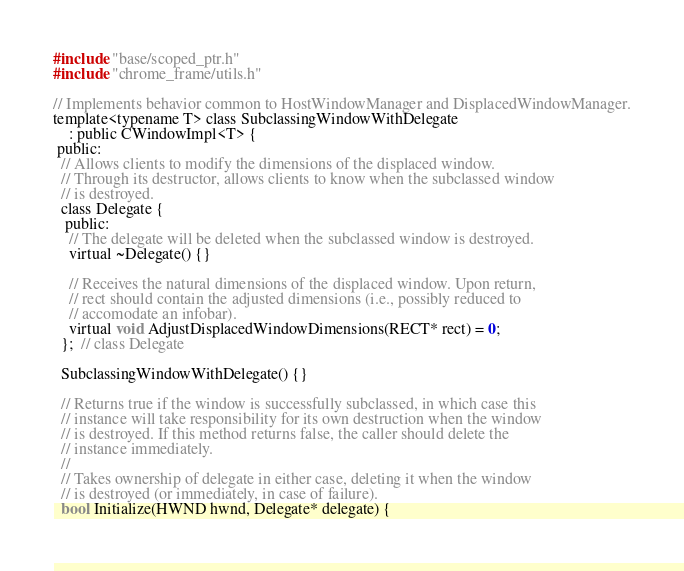Convert code to text. <code><loc_0><loc_0><loc_500><loc_500><_C_>#include "base/scoped_ptr.h"
#include "chrome_frame/utils.h"

// Implements behavior common to HostWindowManager and DisplacedWindowManager.
template<typename T> class SubclassingWindowWithDelegate
    : public CWindowImpl<T> {
 public:
  // Allows clients to modify the dimensions of the displaced window.
  // Through its destructor, allows clients to know when the subclassed window
  // is destroyed.
  class Delegate {
   public:
    // The delegate will be deleted when the subclassed window is destroyed.
    virtual ~Delegate() {}

    // Receives the natural dimensions of the displaced window. Upon return,
    // rect should contain the adjusted dimensions (i.e., possibly reduced to
    // accomodate an infobar).
    virtual void AdjustDisplacedWindowDimensions(RECT* rect) = 0;
  };  // class Delegate

  SubclassingWindowWithDelegate() {}

  // Returns true if the window is successfully subclassed, in which case this
  // instance will take responsibility for its own destruction when the window
  // is destroyed. If this method returns false, the caller should delete the
  // instance immediately.
  //
  // Takes ownership of delegate in either case, deleting it when the window
  // is destroyed (or immediately, in case of failure).
  bool Initialize(HWND hwnd, Delegate* delegate) {</code> 